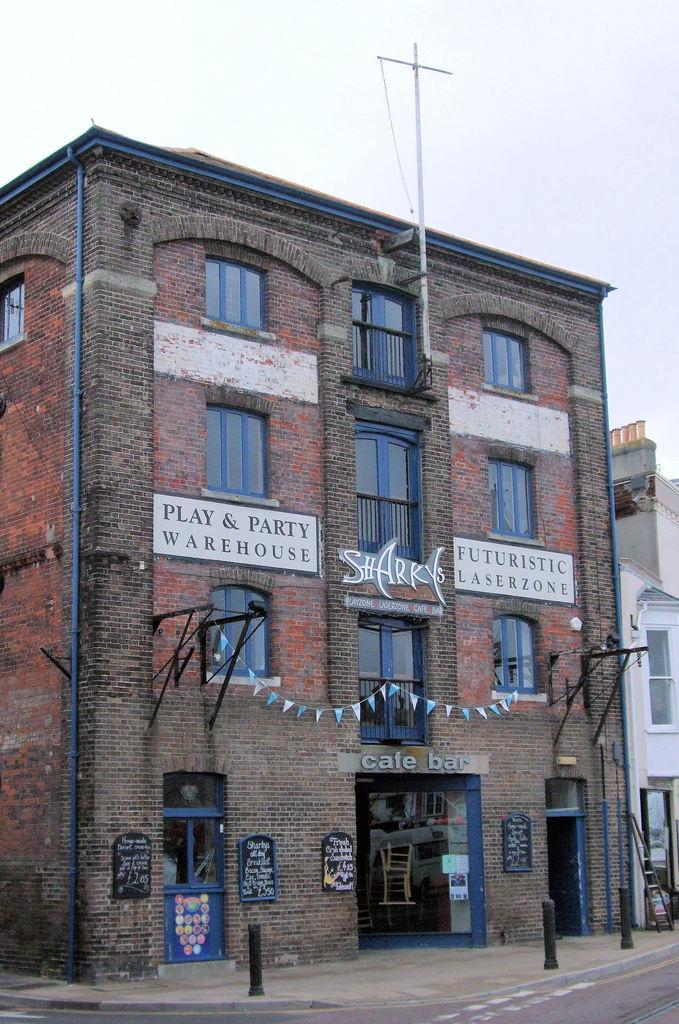Could you give a brief overview of what you see in this image? In this image in the center there are buildings, and some boards and also there are some poles, antenna, and doors, windows, railing. At the bottom there is road, and at the top there is sky. 